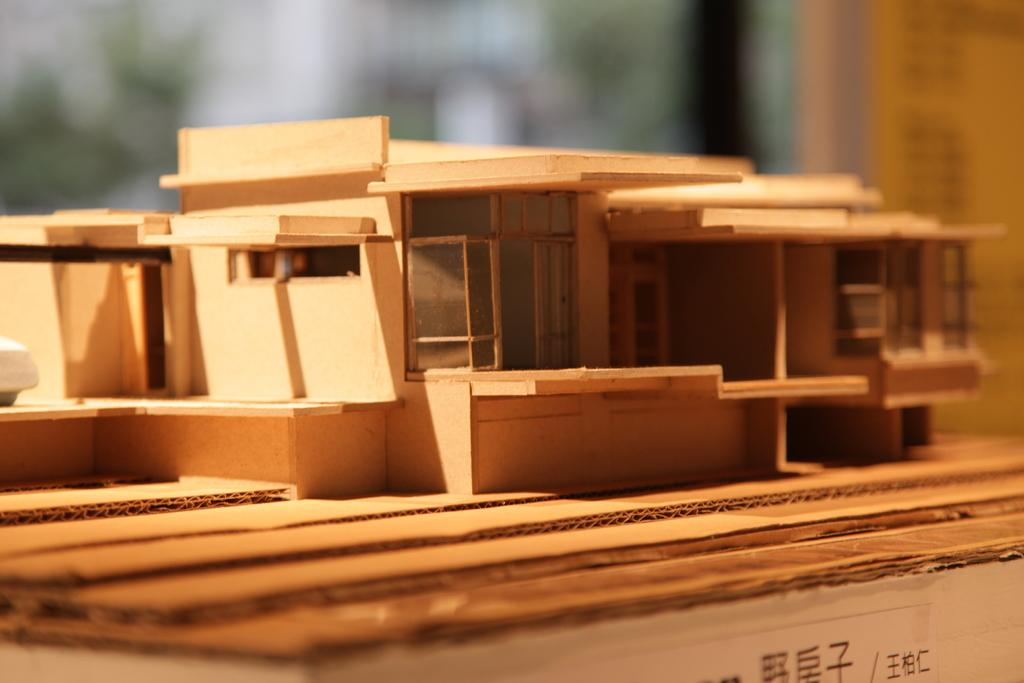What type of toy is present in the image? There is a toy wooden house in the image. What other object can be seen at the bottom of the image? There is a card box at the bottom of the image. Can you describe the background of the image? The background of the image is blurred. What type of book is the person reading in the image? There is no person or book present in the image; it only features a toy wooden house and a card box. 